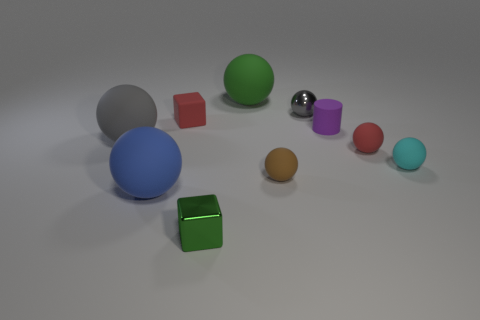Subtract all cyan spheres. How many spheres are left? 6 Subtract all small cyan balls. How many balls are left? 6 Subtract 3 balls. How many balls are left? 4 Subtract all blue spheres. Subtract all yellow cylinders. How many spheres are left? 6 Subtract all cylinders. How many objects are left? 9 Add 5 purple things. How many purple things exist? 6 Subtract 1 red spheres. How many objects are left? 9 Subtract all gray matte spheres. Subtract all gray objects. How many objects are left? 7 Add 9 tiny red rubber blocks. How many tiny red rubber blocks are left? 10 